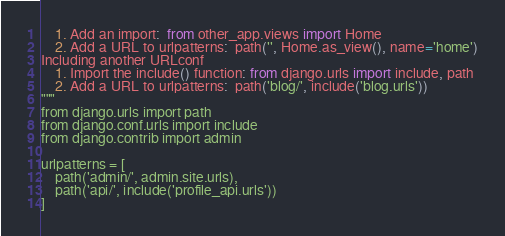Convert code to text. <code><loc_0><loc_0><loc_500><loc_500><_Python_>    1. Add an import:  from other_app.views import Home
    2. Add a URL to urlpatterns:  path('', Home.as_view(), name='home')
Including another URLconf
    1. Import the include() function: from django.urls import include, path
    2. Add a URL to urlpatterns:  path('blog/', include('blog.urls'))
"""
from django.urls import path
from django.conf.urls import include
from django.contrib import admin

urlpatterns = [
    path('admin/', admin.site.urls),
    path('api/', include('profile_api.urls'))
]
</code> 